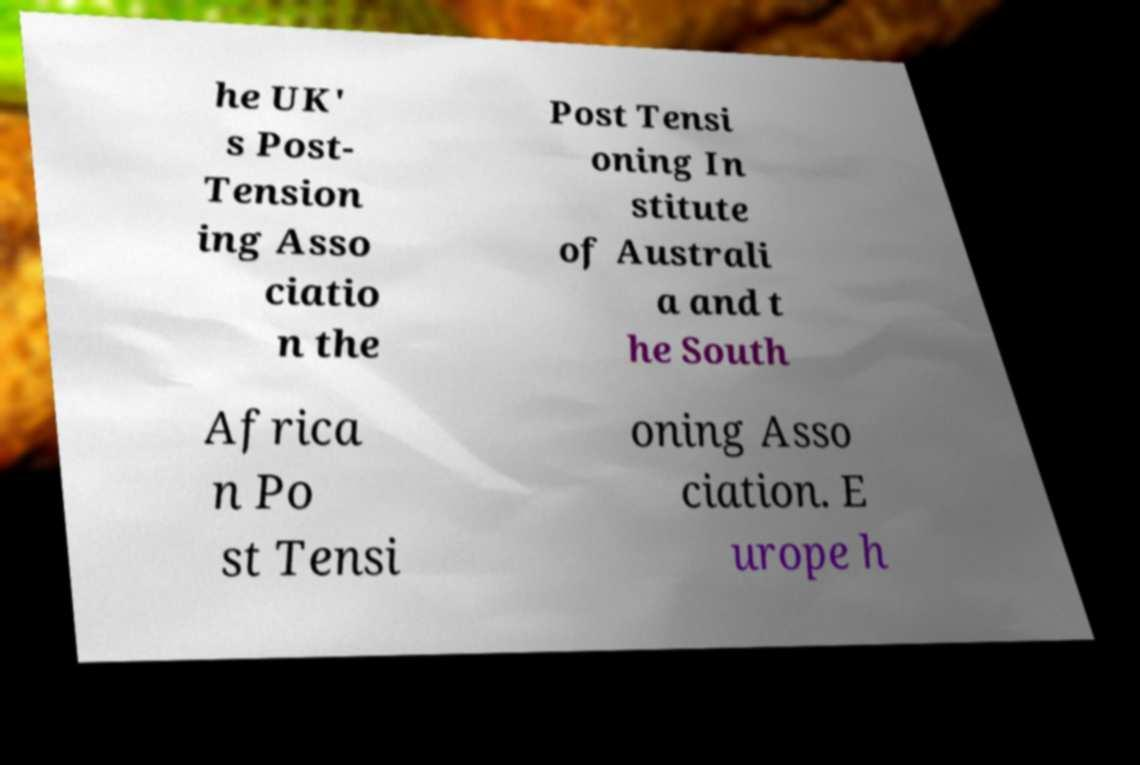Please read and relay the text visible in this image. What does it say? he UK' s Post- Tension ing Asso ciatio n the Post Tensi oning In stitute of Australi a and t he South Africa n Po st Tensi oning Asso ciation. E urope h 